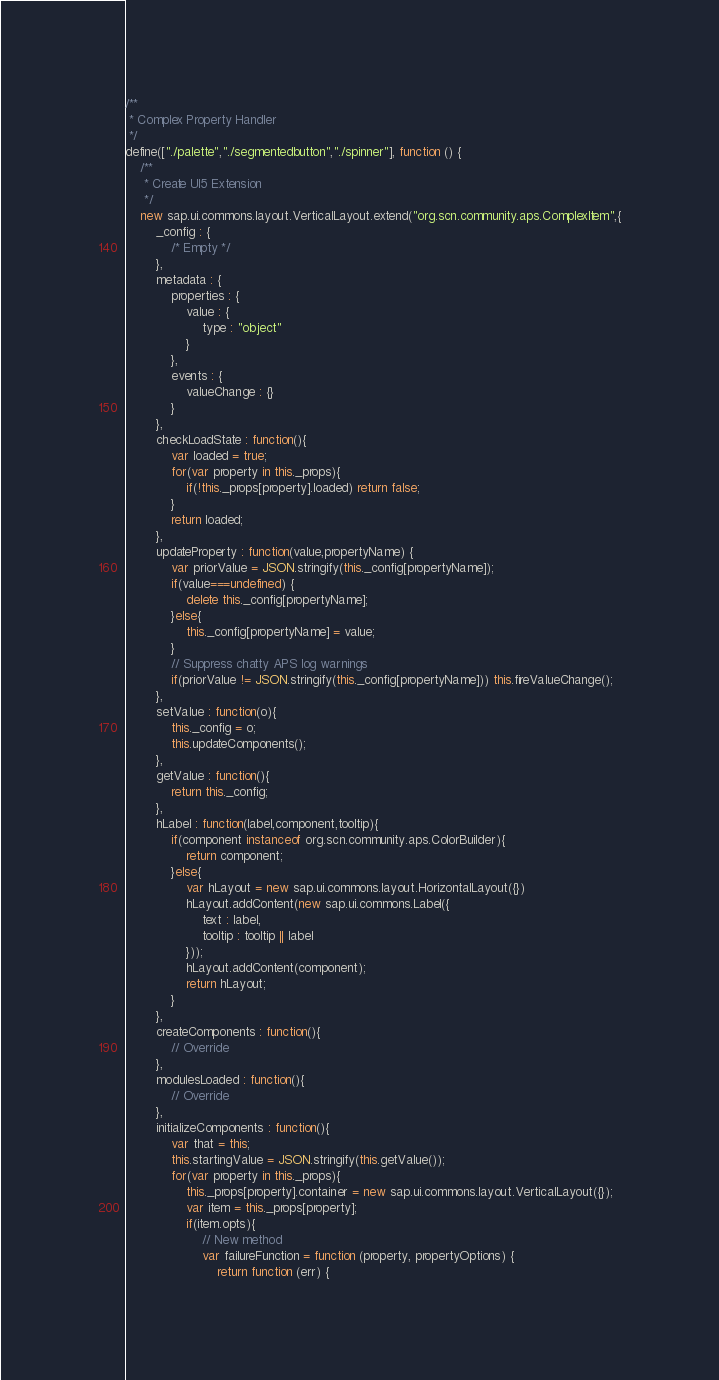<code> <loc_0><loc_0><loc_500><loc_500><_JavaScript_>/**
 * Complex Property Handler
 */
define(["./palette","./segmentedbutton","./spinner"], function () {
	/**
	 * Create UI5 Extension
	 */
	new sap.ui.commons.layout.VerticalLayout.extend("org.scn.community.aps.ComplexItem",{
		_config : {
			/* Empty */
		},
		metadata : {
			properties : {
				value : {
					type : "object"
				}
			},
			events : {
				valueChange : {}
			}
		},
		checkLoadState : function(){
			var loaded = true;
			for(var property in this._props){
				if(!this._props[property].loaded) return false;
			}
			return loaded;
		},
		updateProperty : function(value,propertyName) {
			var priorValue = JSON.stringify(this._config[propertyName]);
			if(value===undefined) {
				delete this._config[propertyName];
			}else{
				this._config[propertyName] = value;
			}
			// Suppress chatty APS log warnings
			if(priorValue != JSON.stringify(this._config[propertyName])) this.fireValueChange();
		},
		setValue : function(o){
			this._config = o;
			this.updateComponents();
		},
		getValue : function(){
			return this._config;
		},
		hLabel : function(label,component,tooltip){
			if(component instanceof org.scn.community.aps.ColorBuilder){
				return component;
			}else{
				var hLayout = new sap.ui.commons.layout.HorizontalLayout({})
				hLayout.addContent(new sap.ui.commons.Label({
					text : label,
					tooltip : tooltip || label
				}));
				hLayout.addContent(component);
				return hLayout;
			}
		},
		createComponents : function(){
			// Override
		},
		modulesLoaded : function(){
			// Override
		},
		initializeComponents : function(){
			var that = this;
			this.startingValue = JSON.stringify(this.getValue());
			for(var property in this._props){
				this._props[property].container = new sap.ui.commons.layout.VerticalLayout({});
				var item = this._props[property];
				if(item.opts){
					// New method
					var failureFunction = function (property, propertyOptions) {
						return function (err) {</code> 